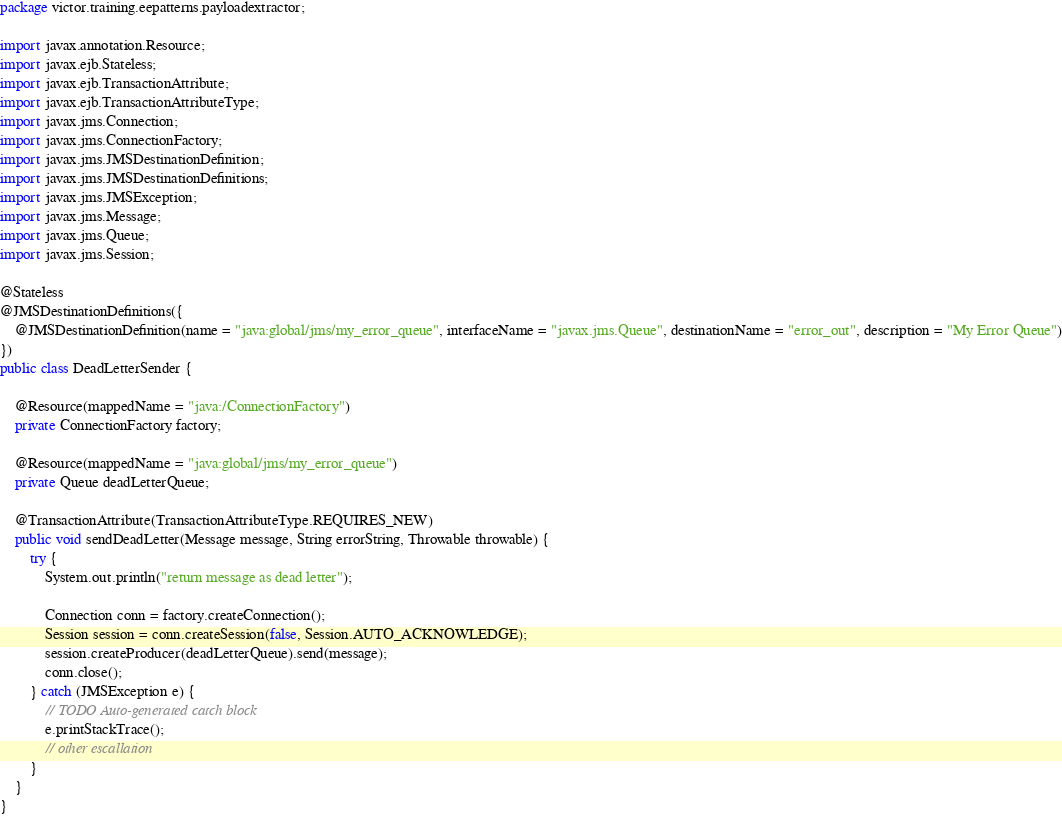Convert code to text. <code><loc_0><loc_0><loc_500><loc_500><_Java_>package victor.training.eepatterns.payloadextractor;

import javax.annotation.Resource;
import javax.ejb.Stateless;
import javax.ejb.TransactionAttribute;
import javax.ejb.TransactionAttributeType;
import javax.jms.Connection;
import javax.jms.ConnectionFactory;
import javax.jms.JMSDestinationDefinition;
import javax.jms.JMSDestinationDefinitions;
import javax.jms.JMSException;
import javax.jms.Message;
import javax.jms.Queue;
import javax.jms.Session;

@Stateless
@JMSDestinationDefinitions({
	@JMSDestinationDefinition(name = "java:global/jms/my_error_queue", interfaceName = "javax.jms.Queue", destinationName = "error_out", description = "My Error Queue")
})
public class DeadLetterSender {

	@Resource(mappedName = "java:/ConnectionFactory")
	private ConnectionFactory factory;

	@Resource(mappedName = "java:global/jms/my_error_queue")
	private Queue deadLetterQueue;

	@TransactionAttribute(TransactionAttributeType.REQUIRES_NEW)
	public void sendDeadLetter(Message message, String errorString, Throwable throwable) {
		try {
			System.out.println("return message as dead letter");

			Connection conn = factory.createConnection();
			Session session = conn.createSession(false, Session.AUTO_ACKNOWLEDGE);
			session.createProducer(deadLetterQueue).send(message);
			conn.close();
		} catch (JMSException e) {
			// TODO Auto-generated catch block
			e.printStackTrace();
			// other escallation
		}
	}
}
</code> 